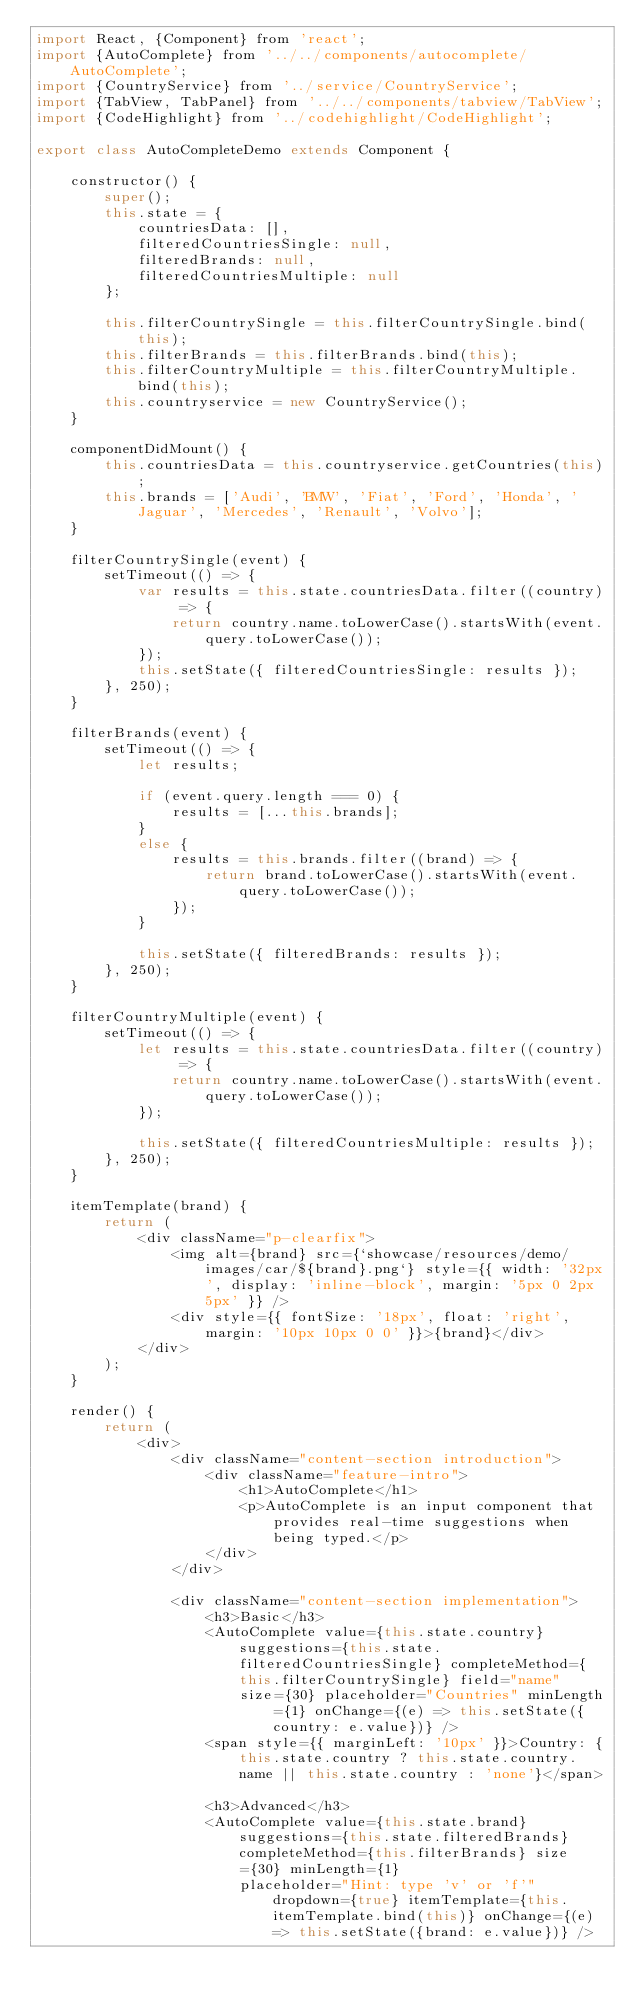<code> <loc_0><loc_0><loc_500><loc_500><_JavaScript_>import React, {Component} from 'react';
import {AutoComplete} from '../../components/autocomplete/AutoComplete';
import {CountryService} from '../service/CountryService';
import {TabView, TabPanel} from '../../components/tabview/TabView';
import {CodeHighlight} from '../codehighlight/CodeHighlight';

export class AutoCompleteDemo extends Component {

    constructor() {
        super();
        this.state = { 
            countriesData: [],
            filteredCountriesSingle: null,
            filteredBrands: null,
            filteredCountriesMultiple: null
        };
        
        this.filterCountrySingle = this.filterCountrySingle.bind(this);
        this.filterBrands = this.filterBrands.bind(this);
        this.filterCountryMultiple = this.filterCountryMultiple.bind(this);
        this.countryservice = new CountryService();
    }

    componentDidMount() {
        this.countriesData = this.countryservice.getCountries(this);
        this.brands = ['Audi', 'BMW', 'Fiat', 'Ford', 'Honda', 'Jaguar', 'Mercedes', 'Renault', 'Volvo'];
    }

    filterCountrySingle(event) {
        setTimeout(() => {
            var results = this.state.countriesData.filter((country) => {
                return country.name.toLowerCase().startsWith(event.query.toLowerCase());
            });
            this.setState({ filteredCountriesSingle: results });
        }, 250);
    }

    filterBrands(event) {
        setTimeout(() => {
            let results;

            if (event.query.length === 0) {
                results = [...this.brands];
            }
            else {
                results = this.brands.filter((brand) => {
                    return brand.toLowerCase().startsWith(event.query.toLowerCase());
                });
            }

            this.setState({ filteredBrands: results });
        }, 250);
    }

    filterCountryMultiple(event) {
        setTimeout(() => {
            let results = this.state.countriesData.filter((country) => {
                return country.name.toLowerCase().startsWith(event.query.toLowerCase());
            });

            this.setState({ filteredCountriesMultiple: results });
        }, 250);
    }

    itemTemplate(brand) {
        return (
            <div className="p-clearfix">
                <img alt={brand} src={`showcase/resources/demo/images/car/${brand}.png`} style={{ width: '32px', display: 'inline-block', margin: '5px 0 2px 5px' }} />
                <div style={{ fontSize: '18px', float: 'right', margin: '10px 10px 0 0' }}>{brand}</div>
            </div>
        );
    }

    render() {
        return (
            <div>
                <div className="content-section introduction">
                    <div className="feature-intro">
                        <h1>AutoComplete</h1>
                        <p>AutoComplete is an input component that provides real-time suggestions when being typed.</p>
                    </div>
                </div>

                <div className="content-section implementation">
                    <h3>Basic</h3>
                    <AutoComplete value={this.state.country} suggestions={this.state.filteredCountriesSingle} completeMethod={this.filterCountrySingle} field="name"
                        size={30} placeholder="Countries" minLength={1} onChange={(e) => this.setState({country: e.value})} />
                    <span style={{ marginLeft: '10px' }}>Country: {this.state.country ? this.state.country.name || this.state.country : 'none'}</span>

                    <h3>Advanced</h3>
                    <AutoComplete value={this.state.brand} suggestions={this.state.filteredBrands} completeMethod={this.filterBrands} size={30} minLength={1}
                        placeholder="Hint: type 'v' or 'f'" dropdown={true} itemTemplate={this.itemTemplate.bind(this)} onChange={(e) => this.setState({brand: e.value})} /></code> 